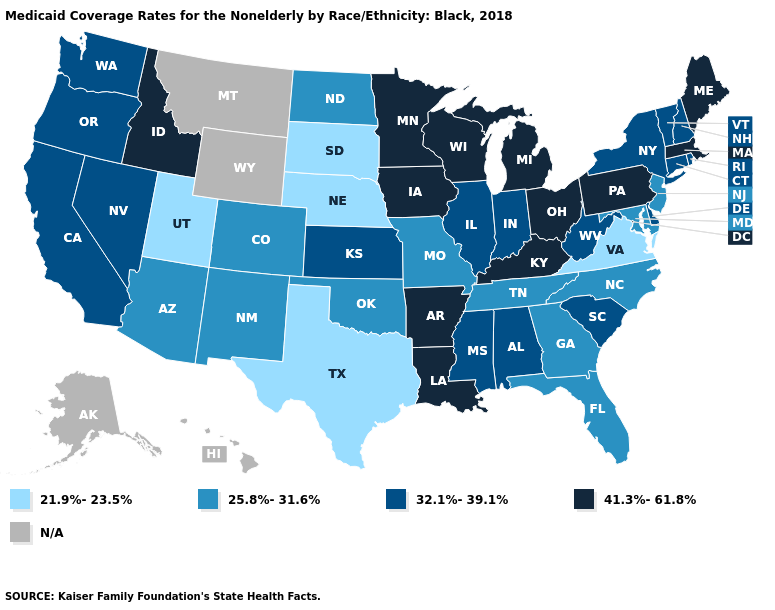What is the value of Missouri?
Write a very short answer. 25.8%-31.6%. Name the states that have a value in the range 21.9%-23.5%?
Give a very brief answer. Nebraska, South Dakota, Texas, Utah, Virginia. Name the states that have a value in the range 41.3%-61.8%?
Be succinct. Arkansas, Idaho, Iowa, Kentucky, Louisiana, Maine, Massachusetts, Michigan, Minnesota, Ohio, Pennsylvania, Wisconsin. Does the first symbol in the legend represent the smallest category?
Concise answer only. Yes. Among the states that border New Jersey , which have the highest value?
Concise answer only. Pennsylvania. Name the states that have a value in the range 21.9%-23.5%?
Keep it brief. Nebraska, South Dakota, Texas, Utah, Virginia. Does Oregon have the lowest value in the USA?
Be succinct. No. Among the states that border Idaho , does Oregon have the highest value?
Quick response, please. Yes. Does the map have missing data?
Quick response, please. Yes. Name the states that have a value in the range N/A?
Give a very brief answer. Alaska, Hawaii, Montana, Wyoming. What is the value of Maine?
Keep it brief. 41.3%-61.8%. What is the value of Mississippi?
Quick response, please. 32.1%-39.1%. Which states have the lowest value in the USA?
Concise answer only. Nebraska, South Dakota, Texas, Utah, Virginia. What is the value of Minnesota?
Give a very brief answer. 41.3%-61.8%. Does the first symbol in the legend represent the smallest category?
Keep it brief. Yes. 